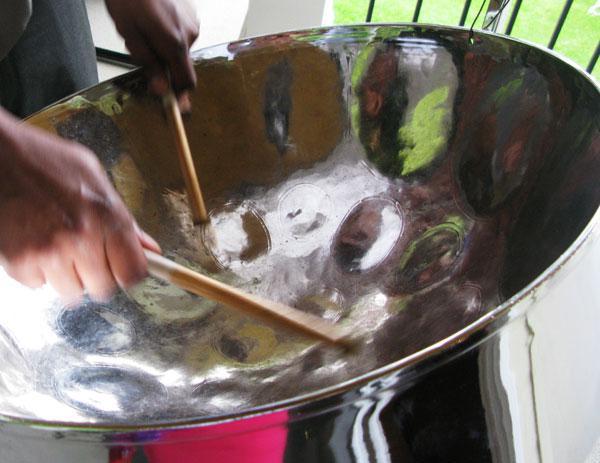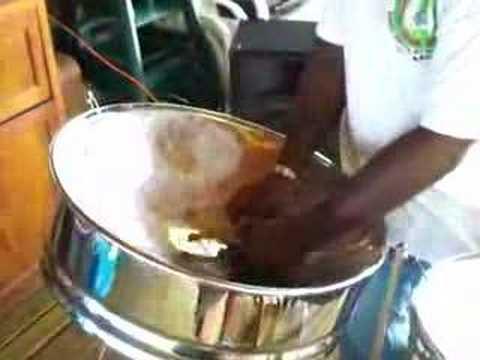The first image is the image on the left, the second image is the image on the right. For the images displayed, is the sentence "One of these steel drums is not being played by a human right now." factually correct? Answer yes or no. No. The first image is the image on the left, the second image is the image on the right. Given the left and right images, does the statement "Each image shows a pair of hands holding a pair of drumsticks inside the concave bowl of a silver drum." hold true? Answer yes or no. Yes. 